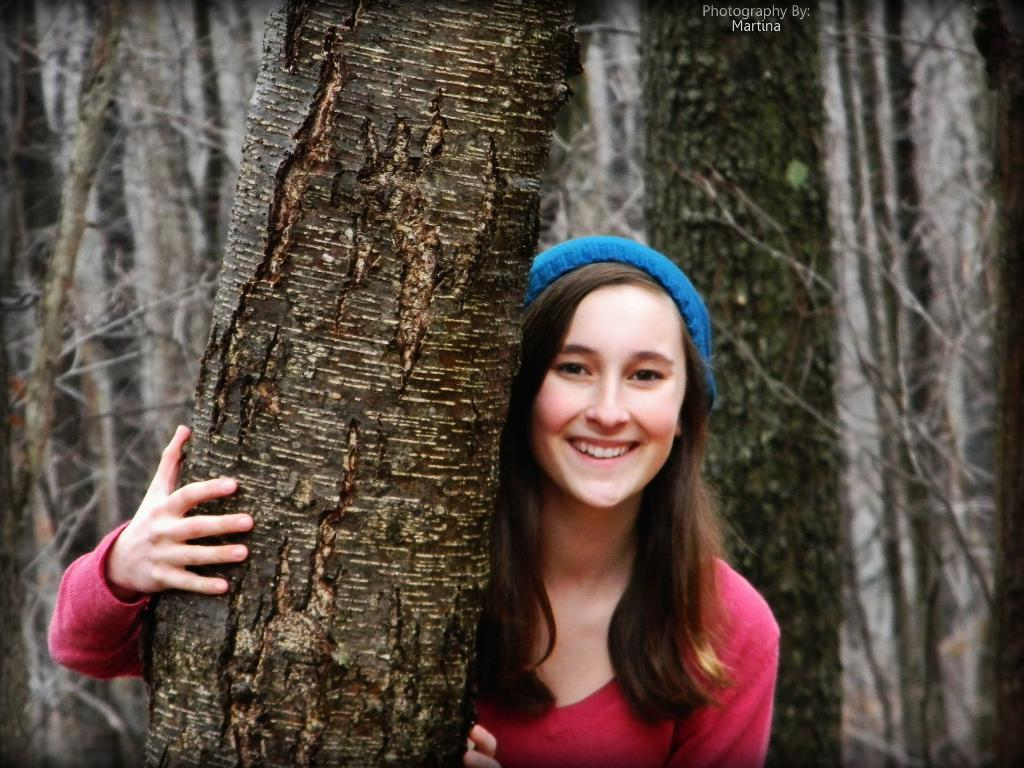Who is the main subject in the image? There is a woman in the image. What is the woman doing in the image? The woman is smiling. What is the woman wearing on her head? The woman is wearing a cap. What type of natural environment can be seen in the image? There are trees visible in the image. What is written or displayed at the top of the image? There is text at the top of the image. Can you see the creator of the trees in the image? There is no creator of the trees visible in the image; we can only see the trees themselves. 